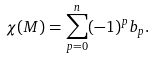<formula> <loc_0><loc_0><loc_500><loc_500>\chi ( M ) = \sum _ { p = 0 } ^ { n } ( - 1 ) ^ { p } b _ { p } .</formula> 